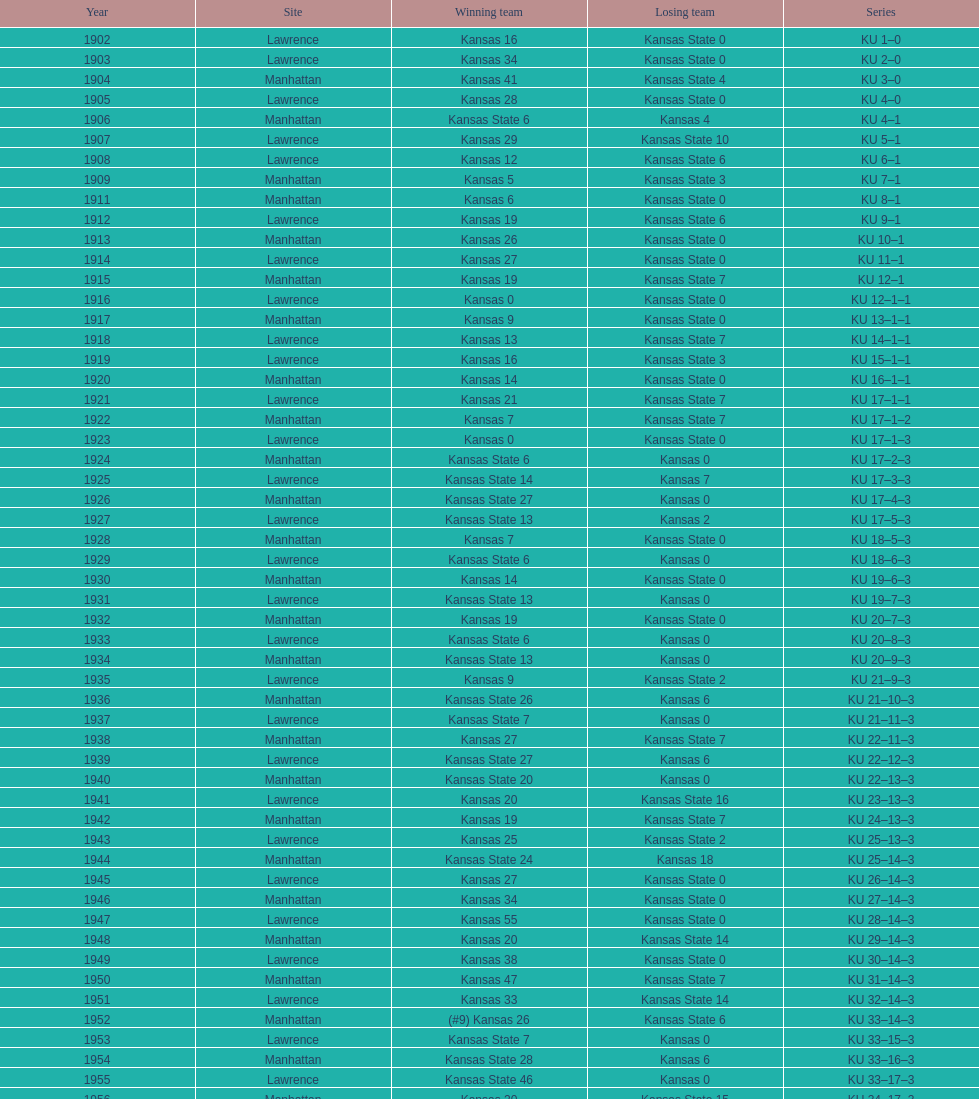When was the first game that kansas state won by double digits? 1926. 